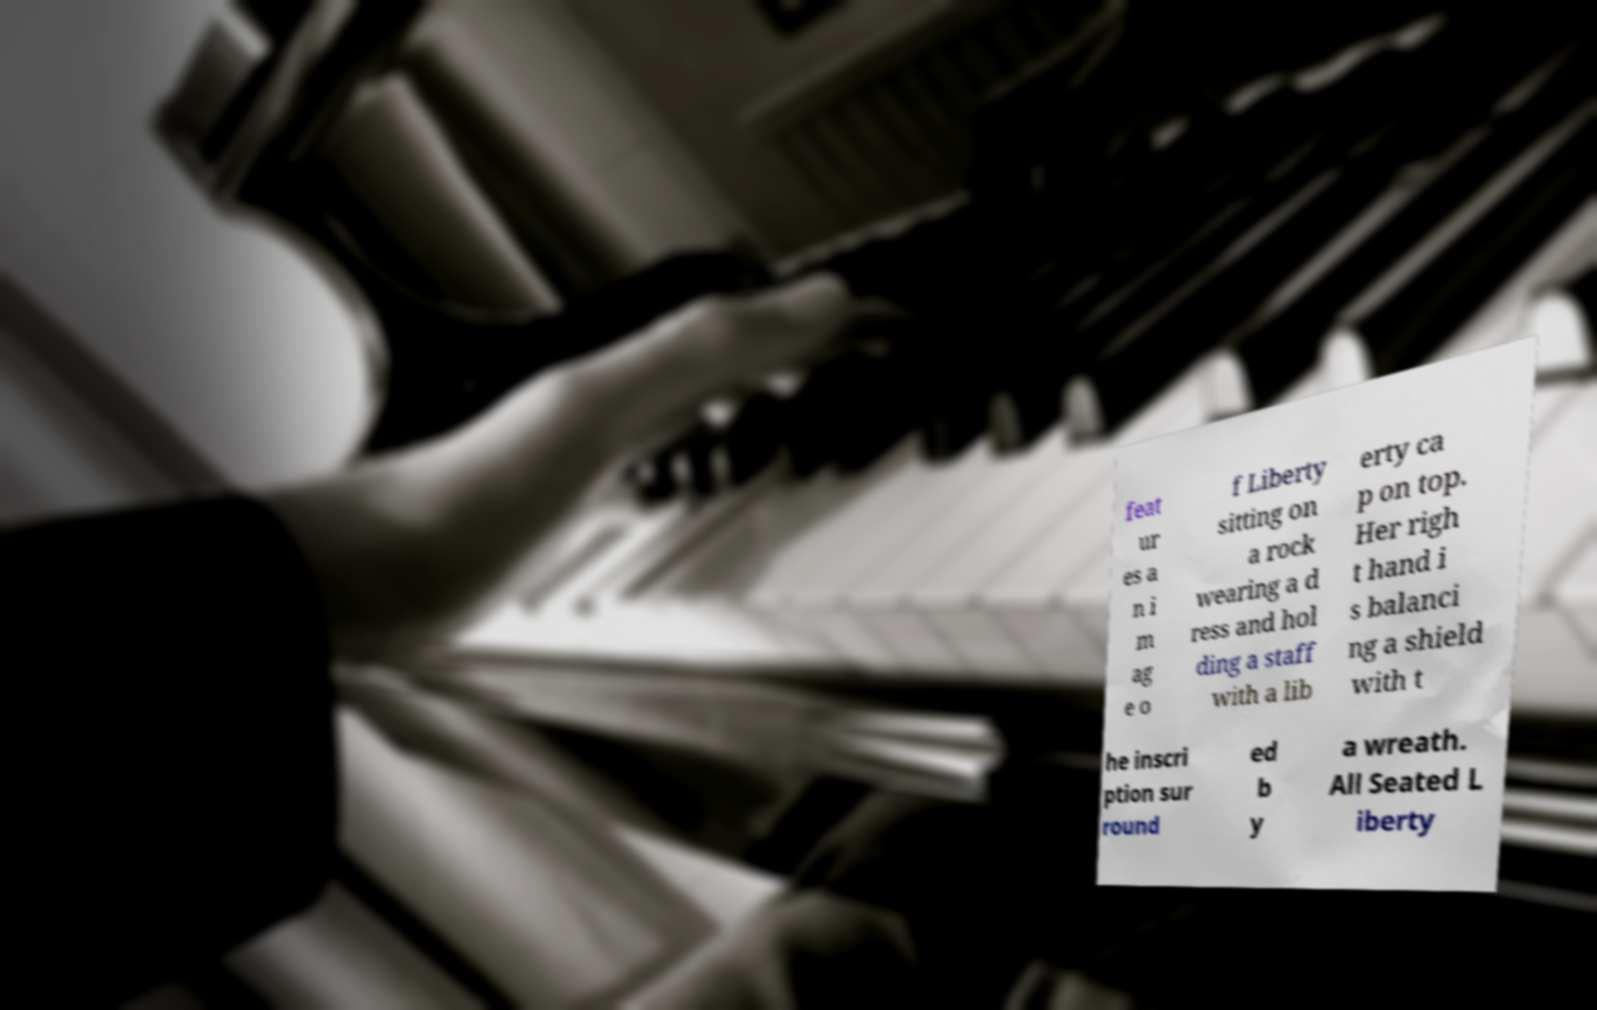Please read and relay the text visible in this image. What does it say? feat ur es a n i m ag e o f Liberty sitting on a rock wearing a d ress and hol ding a staff with a lib erty ca p on top. Her righ t hand i s balanci ng a shield with t he inscri ption sur round ed b y a wreath. All Seated L iberty 